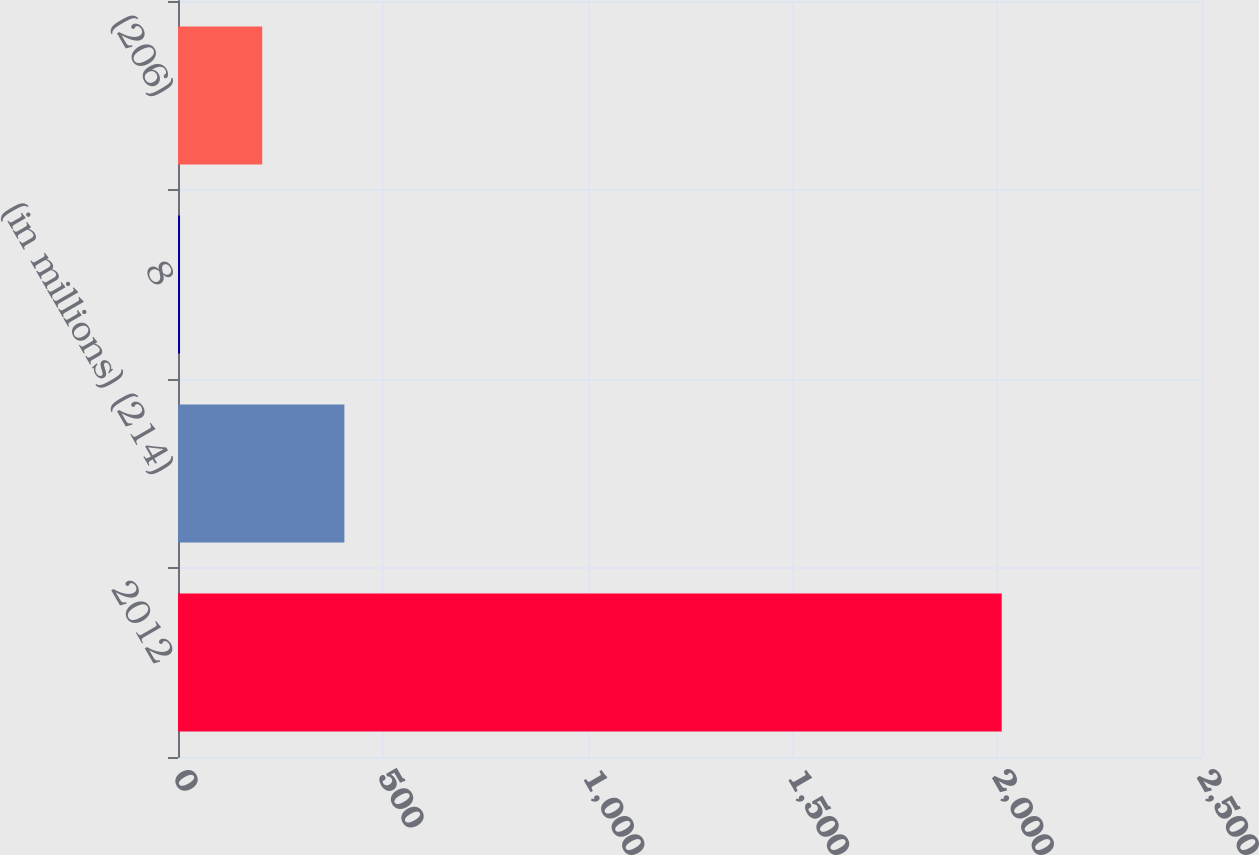Convert chart. <chart><loc_0><loc_0><loc_500><loc_500><bar_chart><fcel>2012<fcel>(in millions) (214)<fcel>8<fcel>(206)<nl><fcel>2011<fcel>406.2<fcel>5<fcel>205.6<nl></chart> 